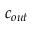Convert formula to latex. <formula><loc_0><loc_0><loc_500><loc_500>c _ { o u t }</formula> 